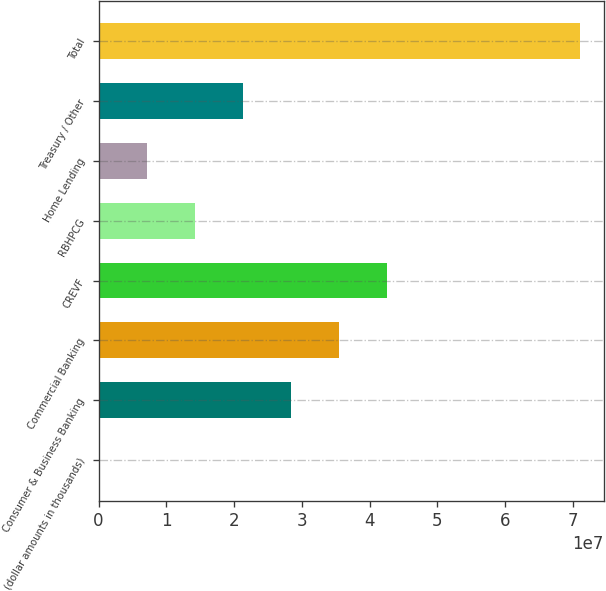Convert chart to OTSL. <chart><loc_0><loc_0><loc_500><loc_500><bar_chart><fcel>(dollar amounts in thousands)<fcel>Consumer & Business Banking<fcel>Commercial Banking<fcel>CREVF<fcel>RBHPCG<fcel>Home Lending<fcel>Treasury / Other<fcel>Total<nl><fcel>2015<fcel>2.84085e+07<fcel>3.55102e+07<fcel>4.26118e+07<fcel>1.42053e+07<fcel>7.10364e+06<fcel>2.13069e+07<fcel>7.10183e+07<nl></chart> 